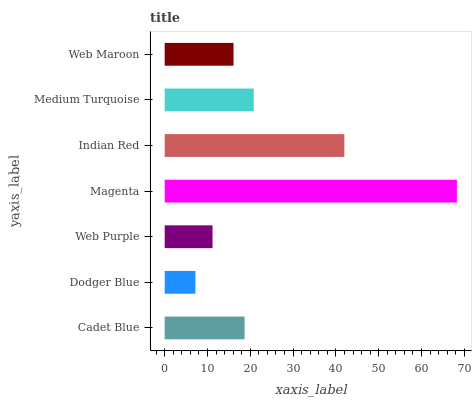Is Dodger Blue the minimum?
Answer yes or no. Yes. Is Magenta the maximum?
Answer yes or no. Yes. Is Web Purple the minimum?
Answer yes or no. No. Is Web Purple the maximum?
Answer yes or no. No. Is Web Purple greater than Dodger Blue?
Answer yes or no. Yes. Is Dodger Blue less than Web Purple?
Answer yes or no. Yes. Is Dodger Blue greater than Web Purple?
Answer yes or no. No. Is Web Purple less than Dodger Blue?
Answer yes or no. No. Is Cadet Blue the high median?
Answer yes or no. Yes. Is Cadet Blue the low median?
Answer yes or no. Yes. Is Dodger Blue the high median?
Answer yes or no. No. Is Web Purple the low median?
Answer yes or no. No. 